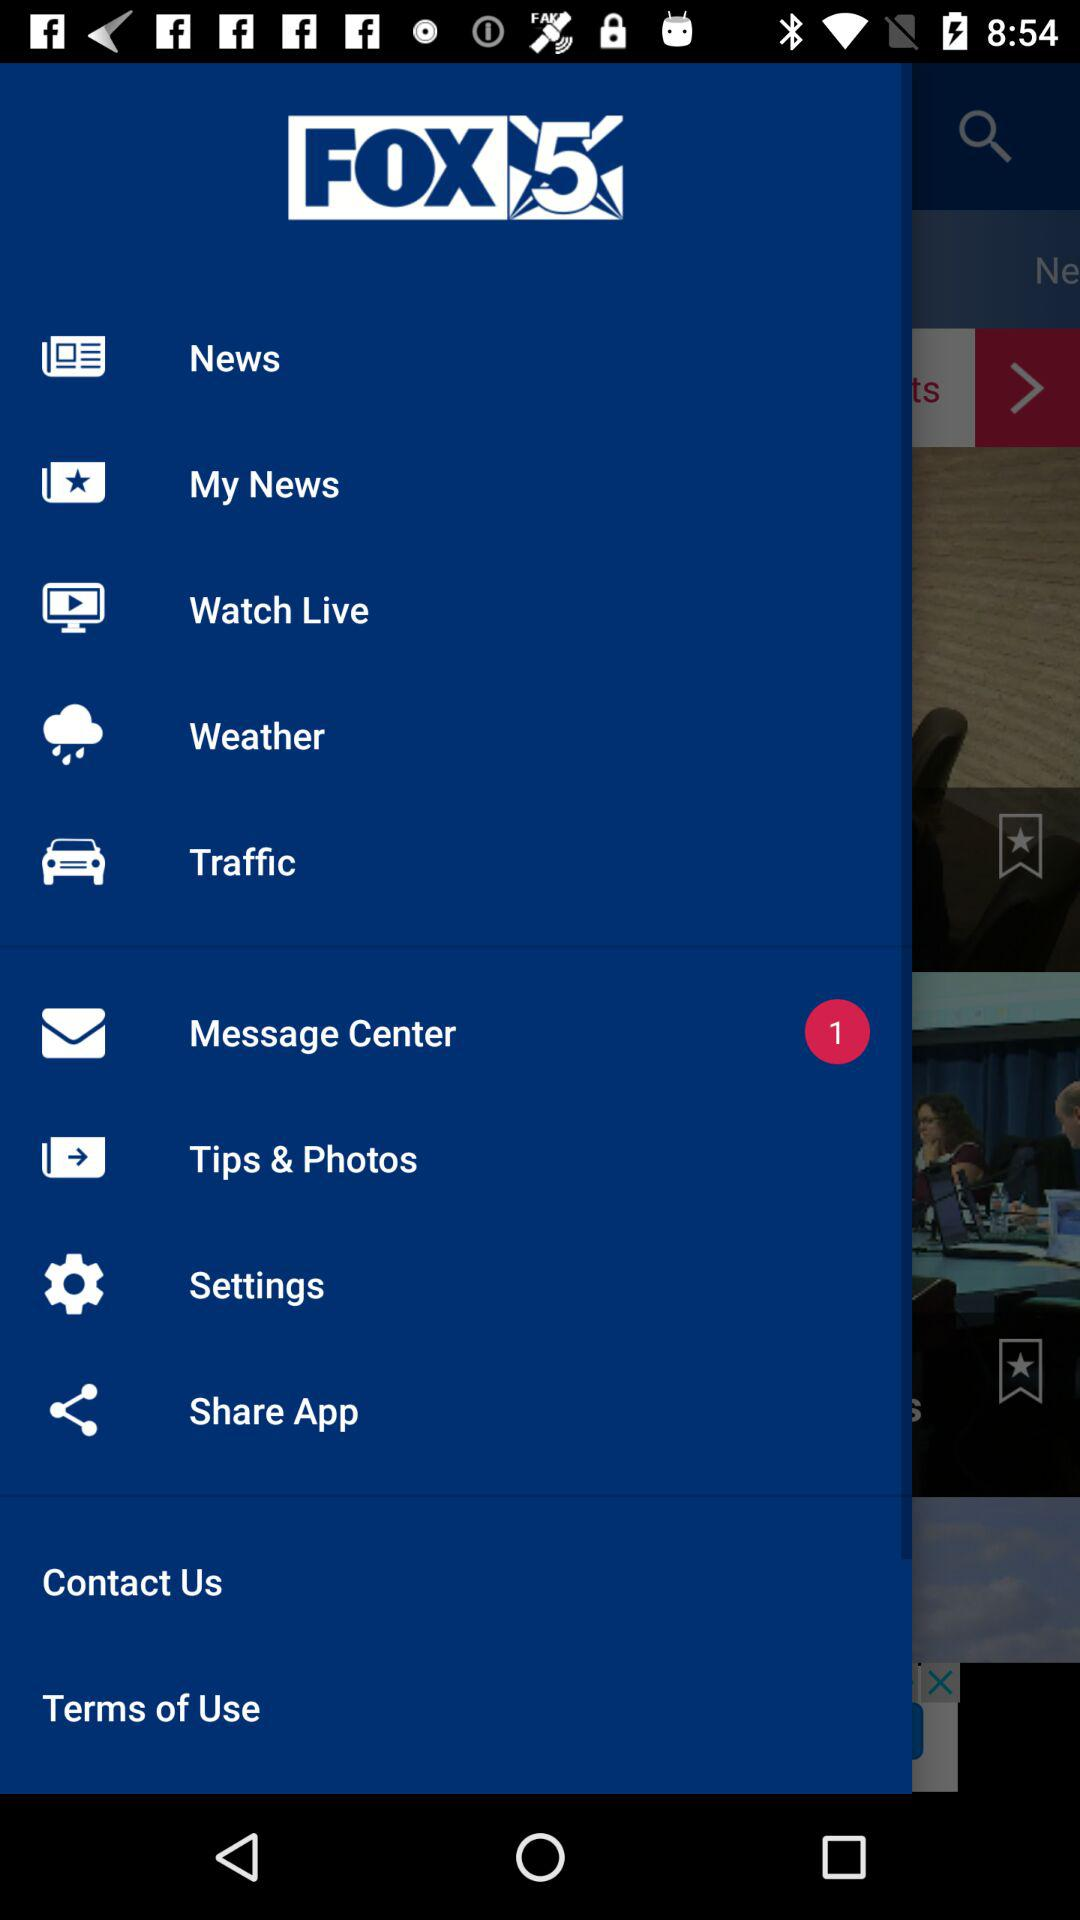How many unread messages are there in the message center? There is only 1 unread message. 